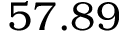Convert formula to latex. <formula><loc_0><loc_0><loc_500><loc_500>5 7 . 8 9</formula> 